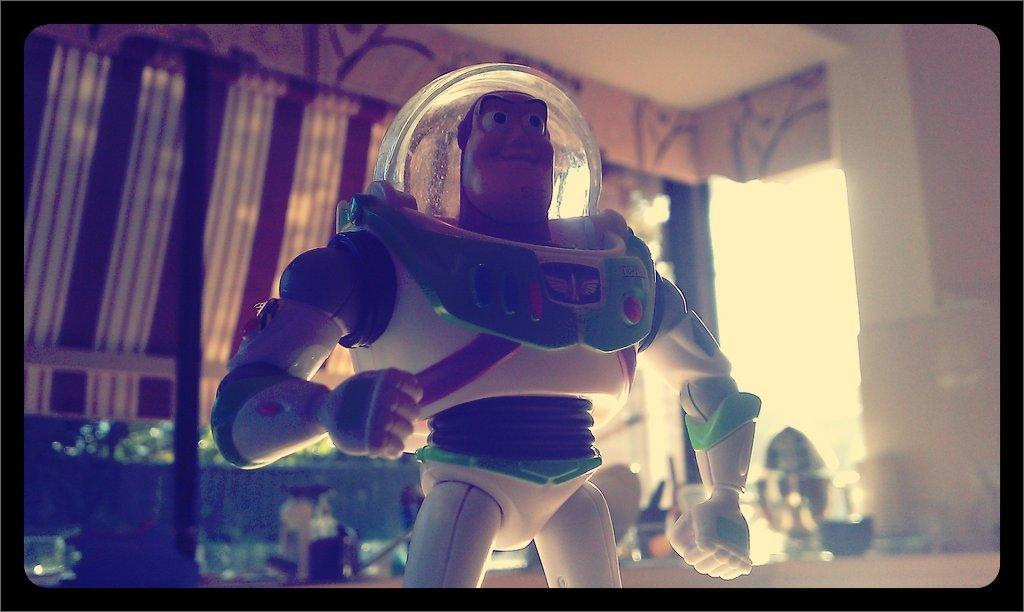What is the main subject in the image? There is a toy in the image. Can you describe the background of the image? There are objects and a wall in the background of the image. What type of material is present in the background of the image? There is cloth in the background of the image. What type of pet can be seen playing with the toy in the image? There is no pet present in the image, and therefore no such activity can be observed. What type of marble is visible on the wall in the image? There is no marble visible on the wall in the image. 